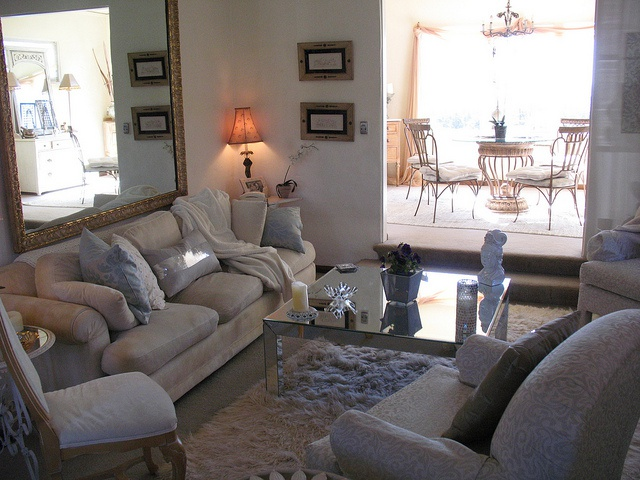Describe the objects in this image and their specific colors. I can see couch in gray, black, and maroon tones, chair in gray and black tones, chair in gray and black tones, chair in gray and black tones, and chair in gray, white, darkgray, and pink tones in this image. 